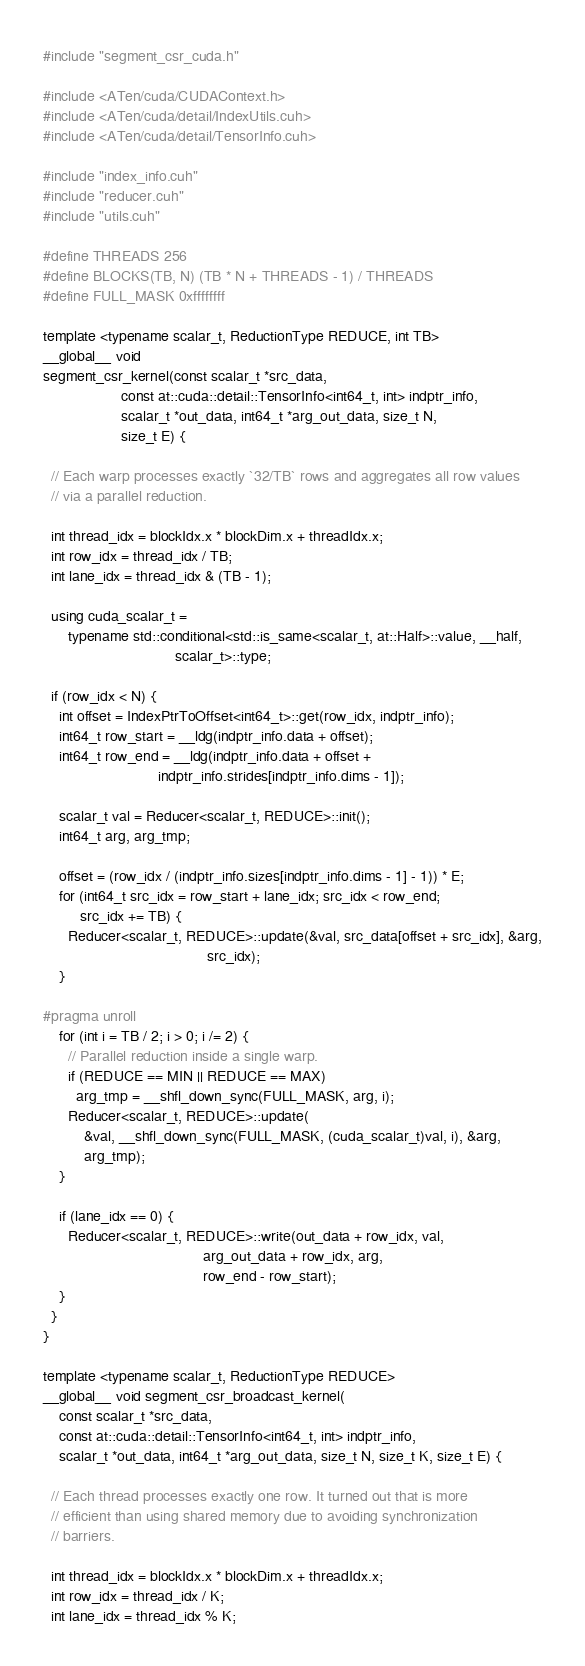<code> <loc_0><loc_0><loc_500><loc_500><_Cuda_>#include "segment_csr_cuda.h"

#include <ATen/cuda/CUDAContext.h>
#include <ATen/cuda/detail/IndexUtils.cuh>
#include <ATen/cuda/detail/TensorInfo.cuh>

#include "index_info.cuh"
#include "reducer.cuh"
#include "utils.cuh"

#define THREADS 256
#define BLOCKS(TB, N) (TB * N + THREADS - 1) / THREADS
#define FULL_MASK 0xffffffff

template <typename scalar_t, ReductionType REDUCE, int TB>
__global__ void
segment_csr_kernel(const scalar_t *src_data,
                   const at::cuda::detail::TensorInfo<int64_t, int> indptr_info,
                   scalar_t *out_data, int64_t *arg_out_data, size_t N,
                   size_t E) {

  // Each warp processes exactly `32/TB` rows and aggregates all row values
  // via a parallel reduction.

  int thread_idx = blockIdx.x * blockDim.x + threadIdx.x;
  int row_idx = thread_idx / TB;
  int lane_idx = thread_idx & (TB - 1);

  using cuda_scalar_t =
      typename std::conditional<std::is_same<scalar_t, at::Half>::value, __half,
                                scalar_t>::type;

  if (row_idx < N) {
    int offset = IndexPtrToOffset<int64_t>::get(row_idx, indptr_info);
    int64_t row_start = __ldg(indptr_info.data + offset);
    int64_t row_end = __ldg(indptr_info.data + offset +
                            indptr_info.strides[indptr_info.dims - 1]);

    scalar_t val = Reducer<scalar_t, REDUCE>::init();
    int64_t arg, arg_tmp;

    offset = (row_idx / (indptr_info.sizes[indptr_info.dims - 1] - 1)) * E;
    for (int64_t src_idx = row_start + lane_idx; src_idx < row_end;
         src_idx += TB) {
      Reducer<scalar_t, REDUCE>::update(&val, src_data[offset + src_idx], &arg,
                                        src_idx);
    }

#pragma unroll
    for (int i = TB / 2; i > 0; i /= 2) {
      // Parallel reduction inside a single warp.
      if (REDUCE == MIN || REDUCE == MAX)
        arg_tmp = __shfl_down_sync(FULL_MASK, arg, i);
      Reducer<scalar_t, REDUCE>::update(
          &val, __shfl_down_sync(FULL_MASK, (cuda_scalar_t)val, i), &arg,
          arg_tmp);
    }

    if (lane_idx == 0) {
      Reducer<scalar_t, REDUCE>::write(out_data + row_idx, val,
                                       arg_out_data + row_idx, arg,
                                       row_end - row_start);
    }
  }
}

template <typename scalar_t, ReductionType REDUCE>
__global__ void segment_csr_broadcast_kernel(
    const scalar_t *src_data,
    const at::cuda::detail::TensorInfo<int64_t, int> indptr_info,
    scalar_t *out_data, int64_t *arg_out_data, size_t N, size_t K, size_t E) {

  // Each thread processes exactly one row. It turned out that is more
  // efficient than using shared memory due to avoiding synchronization
  // barriers.

  int thread_idx = blockIdx.x * blockDim.x + threadIdx.x;
  int row_idx = thread_idx / K;
  int lane_idx = thread_idx % K;
</code> 